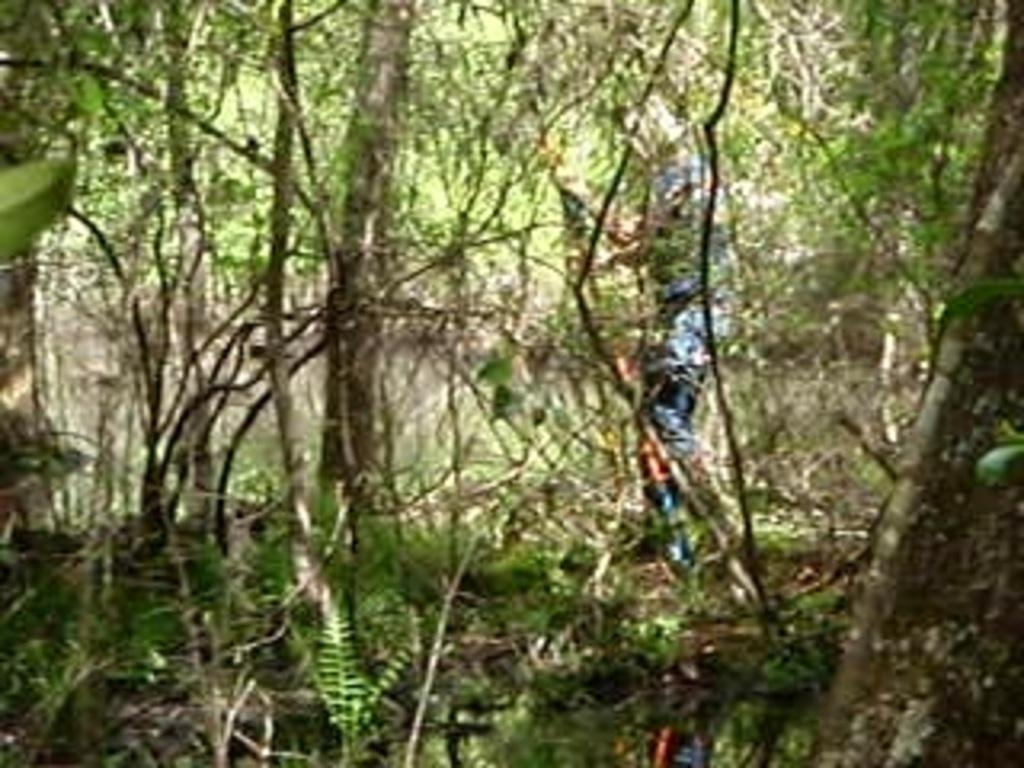Who is present in the image? There is a person in the image. What is the person doing in the image? The person is walking in the image. Where is the person located? The person is in a forest in the image. What can be observed about the forest in the image? There are many trees in the forest in the image. What is the person's annual income in the image? There is no information about the person's income in the image. 